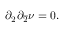Convert formula to latex. <formula><loc_0><loc_0><loc_500><loc_500>\partial _ { 2 } \partial _ { \overline { 2 } } \nu = 0 .</formula> 